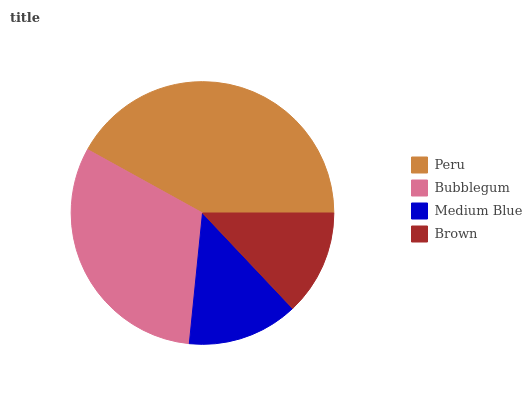Is Brown the minimum?
Answer yes or no. Yes. Is Peru the maximum?
Answer yes or no. Yes. Is Bubblegum the minimum?
Answer yes or no. No. Is Bubblegum the maximum?
Answer yes or no. No. Is Peru greater than Bubblegum?
Answer yes or no. Yes. Is Bubblegum less than Peru?
Answer yes or no. Yes. Is Bubblegum greater than Peru?
Answer yes or no. No. Is Peru less than Bubblegum?
Answer yes or no. No. Is Bubblegum the high median?
Answer yes or no. Yes. Is Medium Blue the low median?
Answer yes or no. Yes. Is Brown the high median?
Answer yes or no. No. Is Brown the low median?
Answer yes or no. No. 